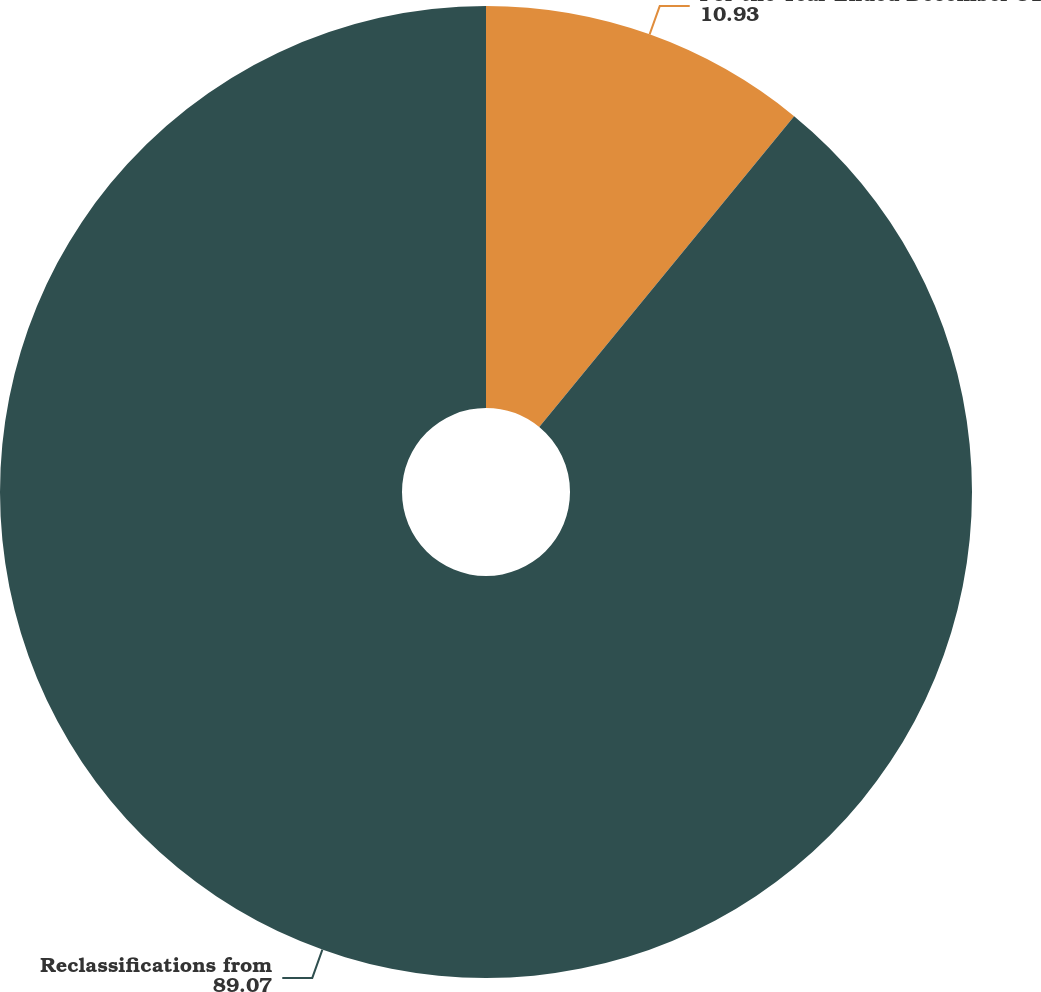<chart> <loc_0><loc_0><loc_500><loc_500><pie_chart><fcel>For the Year Ended December 31<fcel>Reclassifications from<nl><fcel>10.93%<fcel>89.07%<nl></chart> 